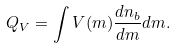Convert formula to latex. <formula><loc_0><loc_0><loc_500><loc_500>Q _ { V } = \int V ( m ) \frac { d n _ { b } } { d m } d m .</formula> 